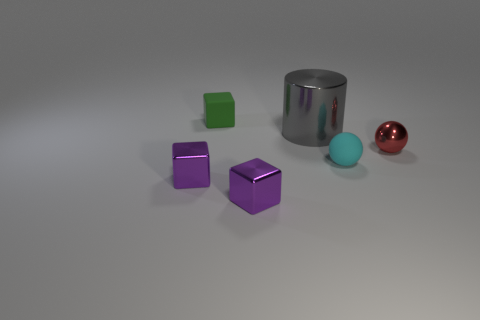Are there any other things that are the same shape as the large object?
Offer a very short reply. No. What number of things are either red balls or tiny cubes in front of the red metal object?
Give a very brief answer. 3. There is a cyan object that is to the right of the big gray cylinder; is its size the same as the purple cube that is on the left side of the tiny green matte cube?
Give a very brief answer. Yes. What number of tiny red metallic things have the same shape as the cyan rubber object?
Offer a terse response. 1. The other small thing that is the same material as the small cyan thing is what shape?
Ensure brevity in your answer.  Cube. What material is the tiny cube behind the tiny cyan thing that is on the right side of the small matte object on the left side of the small cyan sphere made of?
Keep it short and to the point. Rubber. There is a green rubber cube; does it have the same size as the rubber object that is on the right side of the large gray object?
Your answer should be very brief. Yes. There is a red thing that is the same shape as the cyan thing; what material is it?
Keep it short and to the point. Metal. There is a metallic thing behind the small red metallic sphere to the right of the tiny matte thing left of the metallic cylinder; what is its size?
Provide a short and direct response. Large. Is the red shiny object the same size as the cyan matte sphere?
Make the answer very short. Yes. 